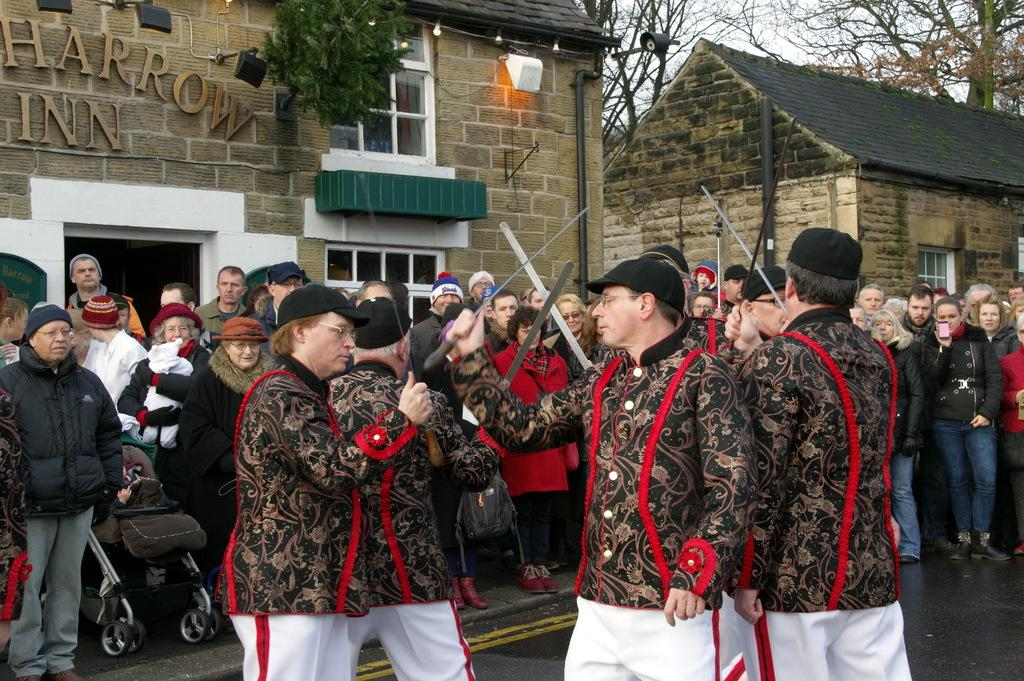What type of structures can be seen in the image? There are buildings in the image. Are there any living beings present in the image? Yes, there are people in the image. What are some of the people holding in the image? Some people are holding knives. What type of unit can be seen in the wilderness in the image? There is no unit or wilderness present in the image; it features buildings and people. Is there a tub visible in the image? There is no tub present in the image. 